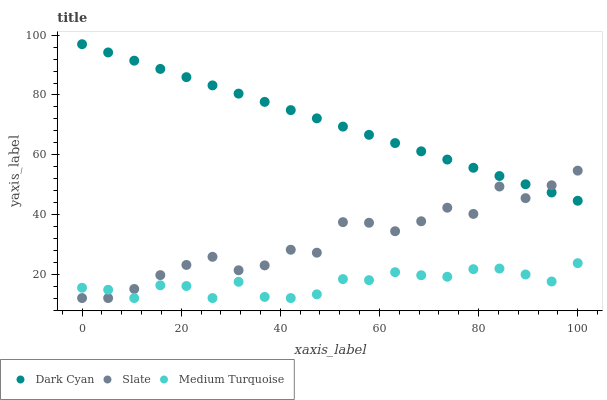Does Medium Turquoise have the minimum area under the curve?
Answer yes or no. Yes. Does Dark Cyan have the maximum area under the curve?
Answer yes or no. Yes. Does Slate have the minimum area under the curve?
Answer yes or no. No. Does Slate have the maximum area under the curve?
Answer yes or no. No. Is Dark Cyan the smoothest?
Answer yes or no. Yes. Is Slate the roughest?
Answer yes or no. Yes. Is Medium Turquoise the smoothest?
Answer yes or no. No. Is Medium Turquoise the roughest?
Answer yes or no. No. Does Slate have the lowest value?
Answer yes or no. Yes. Does Dark Cyan have the highest value?
Answer yes or no. Yes. Does Slate have the highest value?
Answer yes or no. No. Is Medium Turquoise less than Dark Cyan?
Answer yes or no. Yes. Is Dark Cyan greater than Medium Turquoise?
Answer yes or no. Yes. Does Slate intersect Dark Cyan?
Answer yes or no. Yes. Is Slate less than Dark Cyan?
Answer yes or no. No. Is Slate greater than Dark Cyan?
Answer yes or no. No. Does Medium Turquoise intersect Dark Cyan?
Answer yes or no. No. 